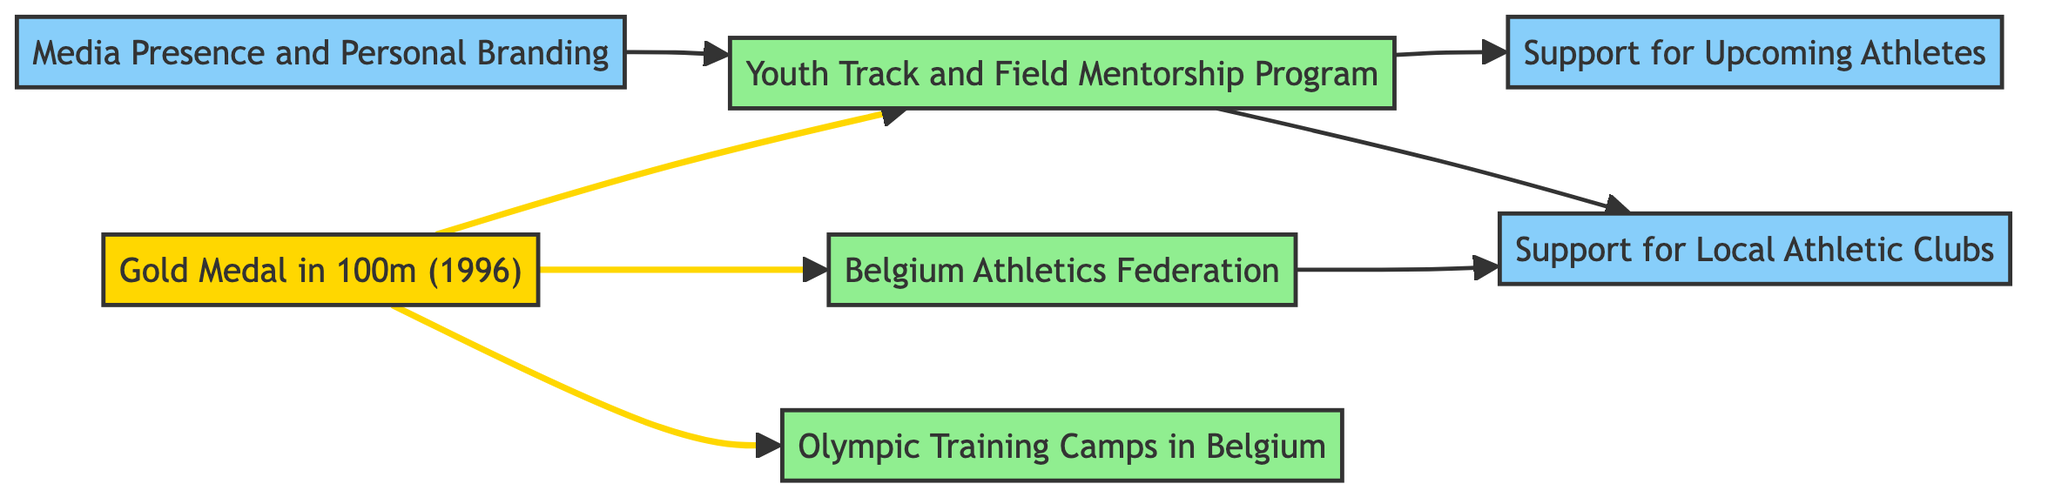What is the central achievement depicted in the diagram? The diagram indicates that the central achievement is represented by the node labeled "Gold Medal in 100m (1996)". This is the starting point from which all other connections radiate.
Answer: Gold Medal in 100m (1996) How many nodes are present in the diagram? By counting the nodes listed in the provided data, we find there are a total of 7 nodes: Gold Medal in 100m (1996), Youth Track and Field Mentorship Program, Belgium Athletics Federation, Olympic Training Camps in Belgium, Support for Local Athletic Clubs, Media Presence and Personal Branding, and Support for Upcoming Athletes.
Answer: 7 Which program is directly influenced by the Gold Medal achievement? According to the edges in the diagram, the node "Youth Track and Field Mentorship Program" is the only one directly influenced by the "Gold Medal in 100m (1996)", as there is a directed edge from the first to the second.
Answer: Youth Track and Field Mentorship Program Which influences emerge from the "Youth Track and Field Mentorship Program"? Analyzing the outgoing edges from the "Youth Track and Field Mentorship Program", we see two direct influences: "Support for Upcoming Athletes" and "Support for Local Athletic Clubs".
Answer: Support for Upcoming Athletes, Support for Local Athletic Clubs What is the role of "Media Presence and Personal Branding" within the diagram? The "Media Presence and Personal Branding" node influences the "Youth Track and Field Mentorship Program", indicating that personal branding contributes to mentorship efforts. Consequently, it plays a supporting role in promoting and establishing the mentorship initiative.
Answer: Influence on Youth Track and Field Mentorship Program How many connections lead to "Support for Local Athletic Clubs"? There are two connections leading to "Support for Local Athletic Clubs": one from "Youth Track and Field Mentorship Program" and another from "Belgium Athletics Federation". Thus, it has multiple sources of influence within the graph.
Answer: 2 What type of connection exists between "Gold Medal in 100m (1996)" and "Belgium Athletics Federation"? The connection between "Gold Medal in 100m (1996)" and "Belgium Athletics Federation" is a direct influence as indicated by the directed edge in the diagram, illustrating that the achievement has a positive effect on the federation.
Answer: Direct influence Which of the programs will most likely support the upcoming athletes according to the diagram? Based on the directed edges, "Youth Track and Field Mentorship Program" is directly connected to "Support for Upcoming Athletes", indicating that through mentorship, the program actively supports upcoming athletes.
Answer: Youth Track and Field Mentorship Program 